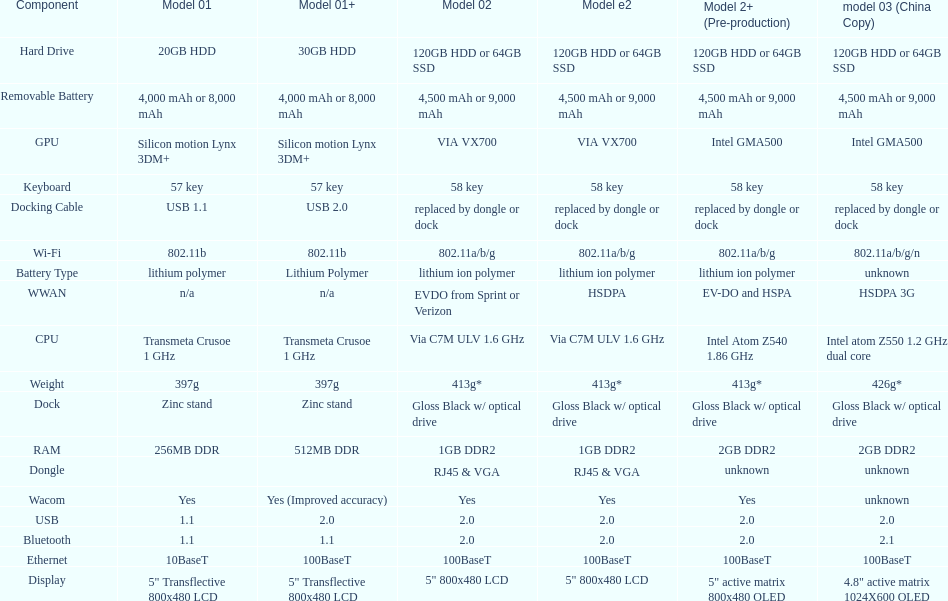What is the next highest hard drive available after the 30gb model? 64GB SSD. 